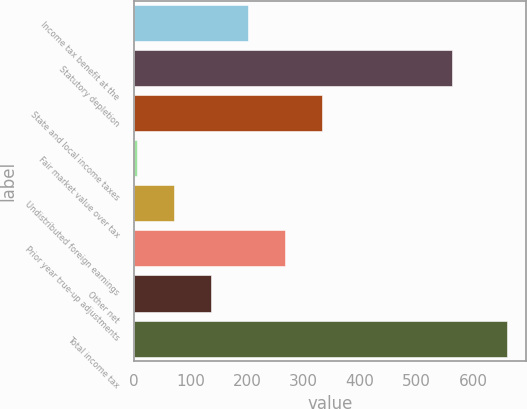Convert chart. <chart><loc_0><loc_0><loc_500><loc_500><bar_chart><fcel>Income tax benefit at the<fcel>Statutory depletion<fcel>State and local income taxes<fcel>Fair market value over tax<fcel>Undistributed foreign earnings<fcel>Prior year true-up adjustments<fcel>Other net<fcel>Total income tax<nl><fcel>201.15<fcel>563.7<fcel>332.39<fcel>4.29<fcel>69.91<fcel>266.77<fcel>135.53<fcel>660.5<nl></chart> 